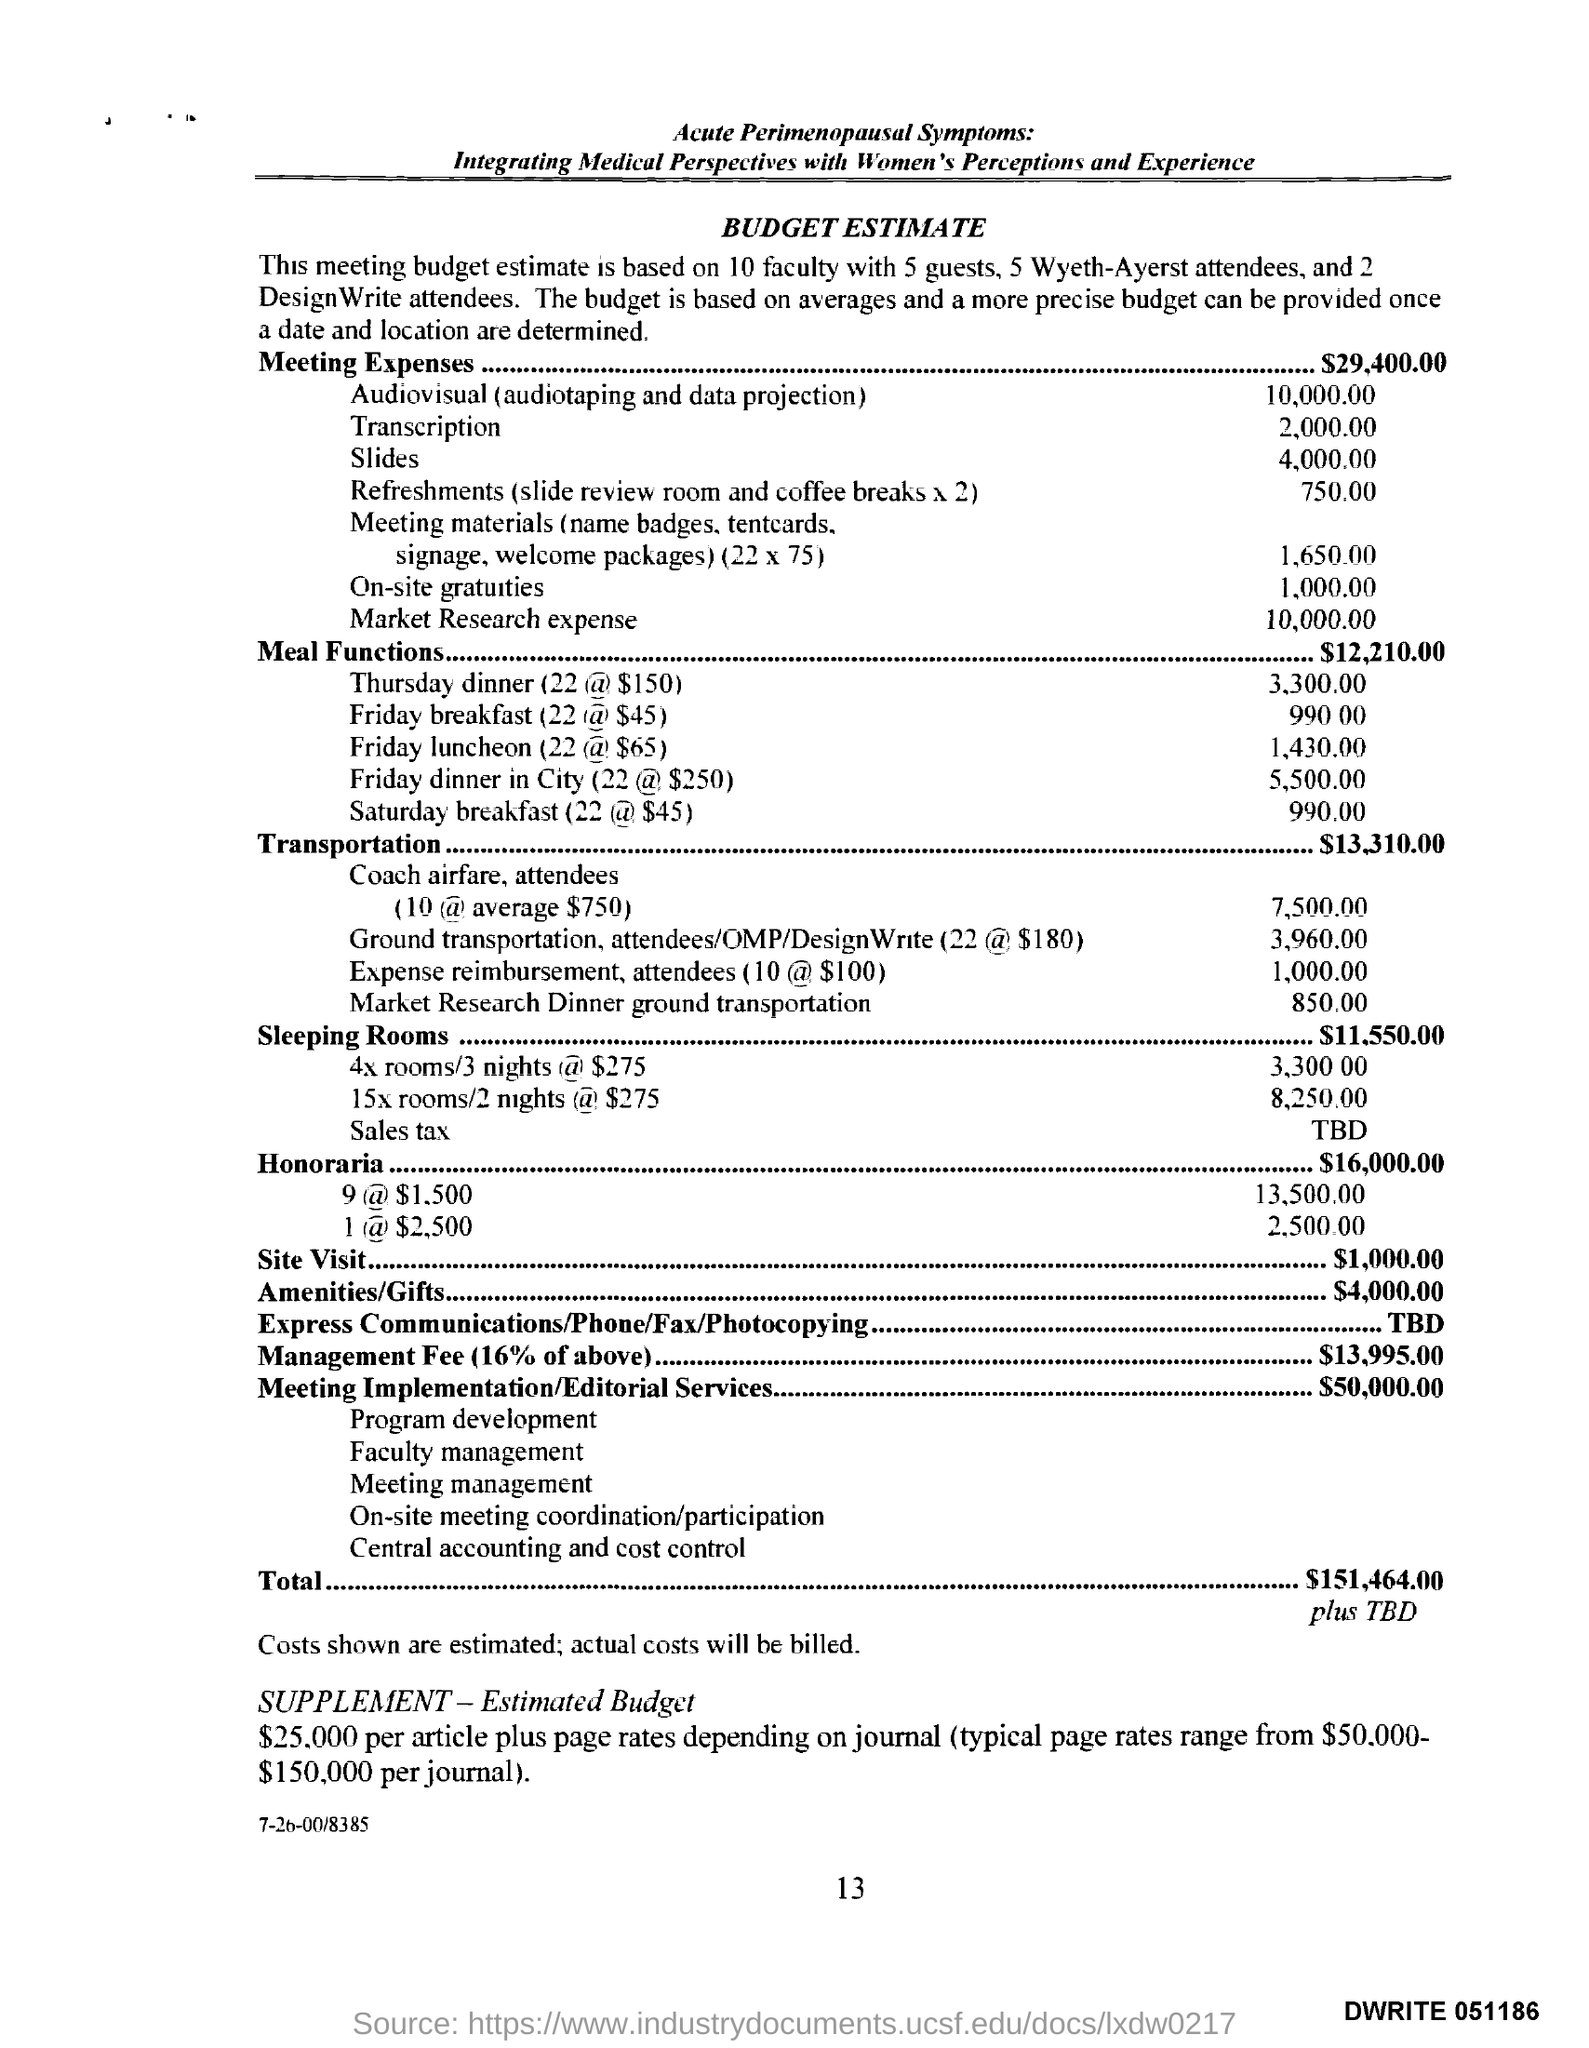Draw attention to some important aspects in this diagram. The amount mentioned for sleeping rooms is $11,550.00. This document refers to a budget estimate. The total amount for the meal functions is $12,210.00 